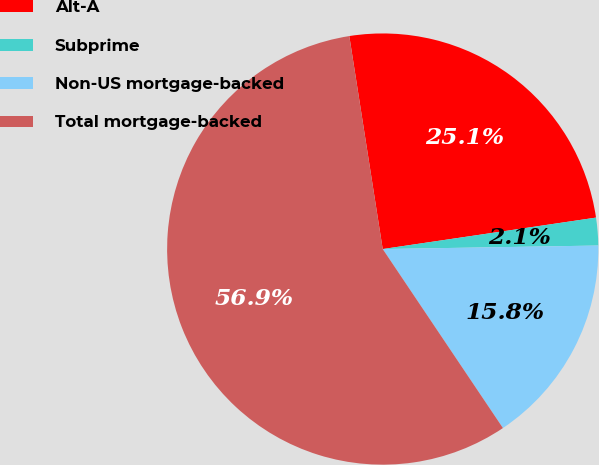<chart> <loc_0><loc_0><loc_500><loc_500><pie_chart><fcel>Alt-A<fcel>Subprime<fcel>Non-US mortgage-backed<fcel>Total mortgage-backed<nl><fcel>25.15%<fcel>2.07%<fcel>15.85%<fcel>56.94%<nl></chart> 